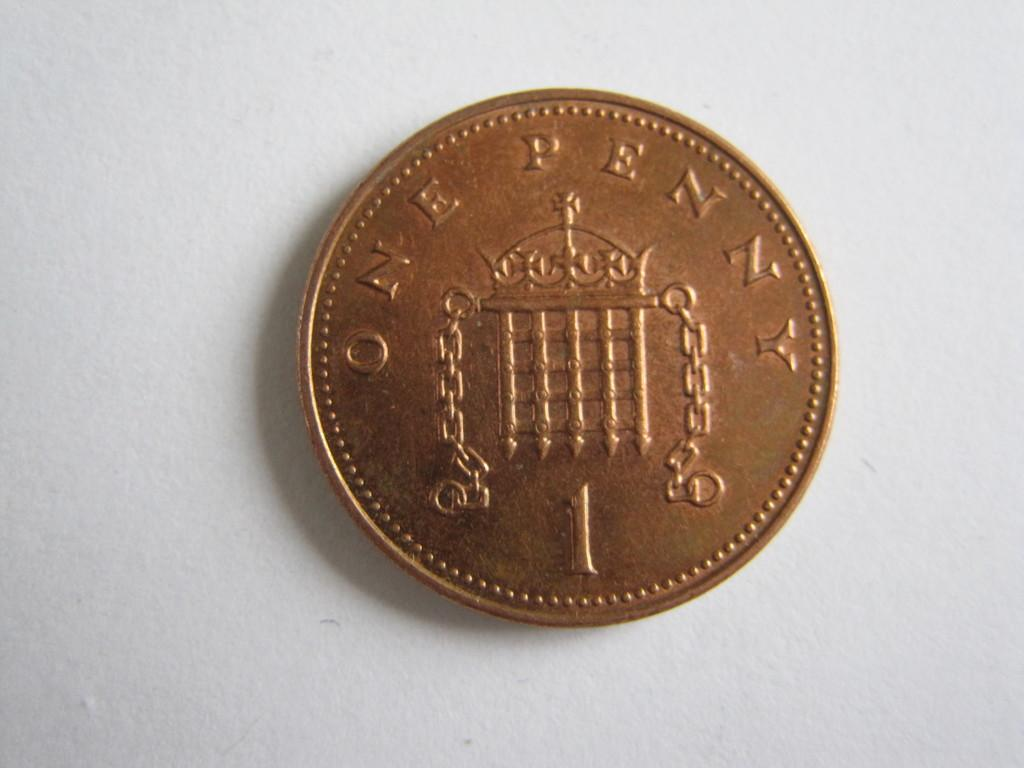<image>
Render a clear and concise summary of the photo. A bronze one penny coin has the number 1 engraved on it. 